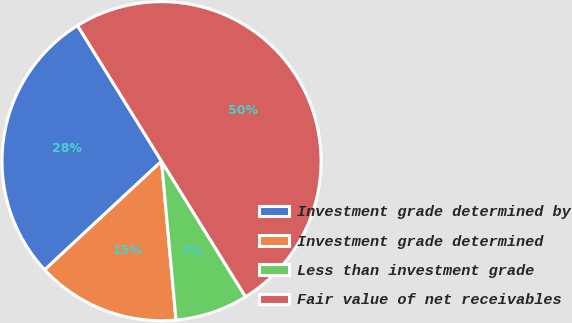<chart> <loc_0><loc_0><loc_500><loc_500><pie_chart><fcel>Investment grade determined by<fcel>Investment grade determined<fcel>Less than investment grade<fcel>Fair value of net receivables<nl><fcel>28.09%<fcel>14.53%<fcel>7.38%<fcel>50.0%<nl></chart> 